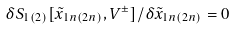Convert formula to latex. <formula><loc_0><loc_0><loc_500><loc_500>\delta S _ { 1 ( 2 ) } [ \tilde { x } _ { 1 n ( 2 n ) } , V ^ { \pm } ] / \delta \tilde { x } _ { 1 n ( 2 n ) } = 0</formula> 